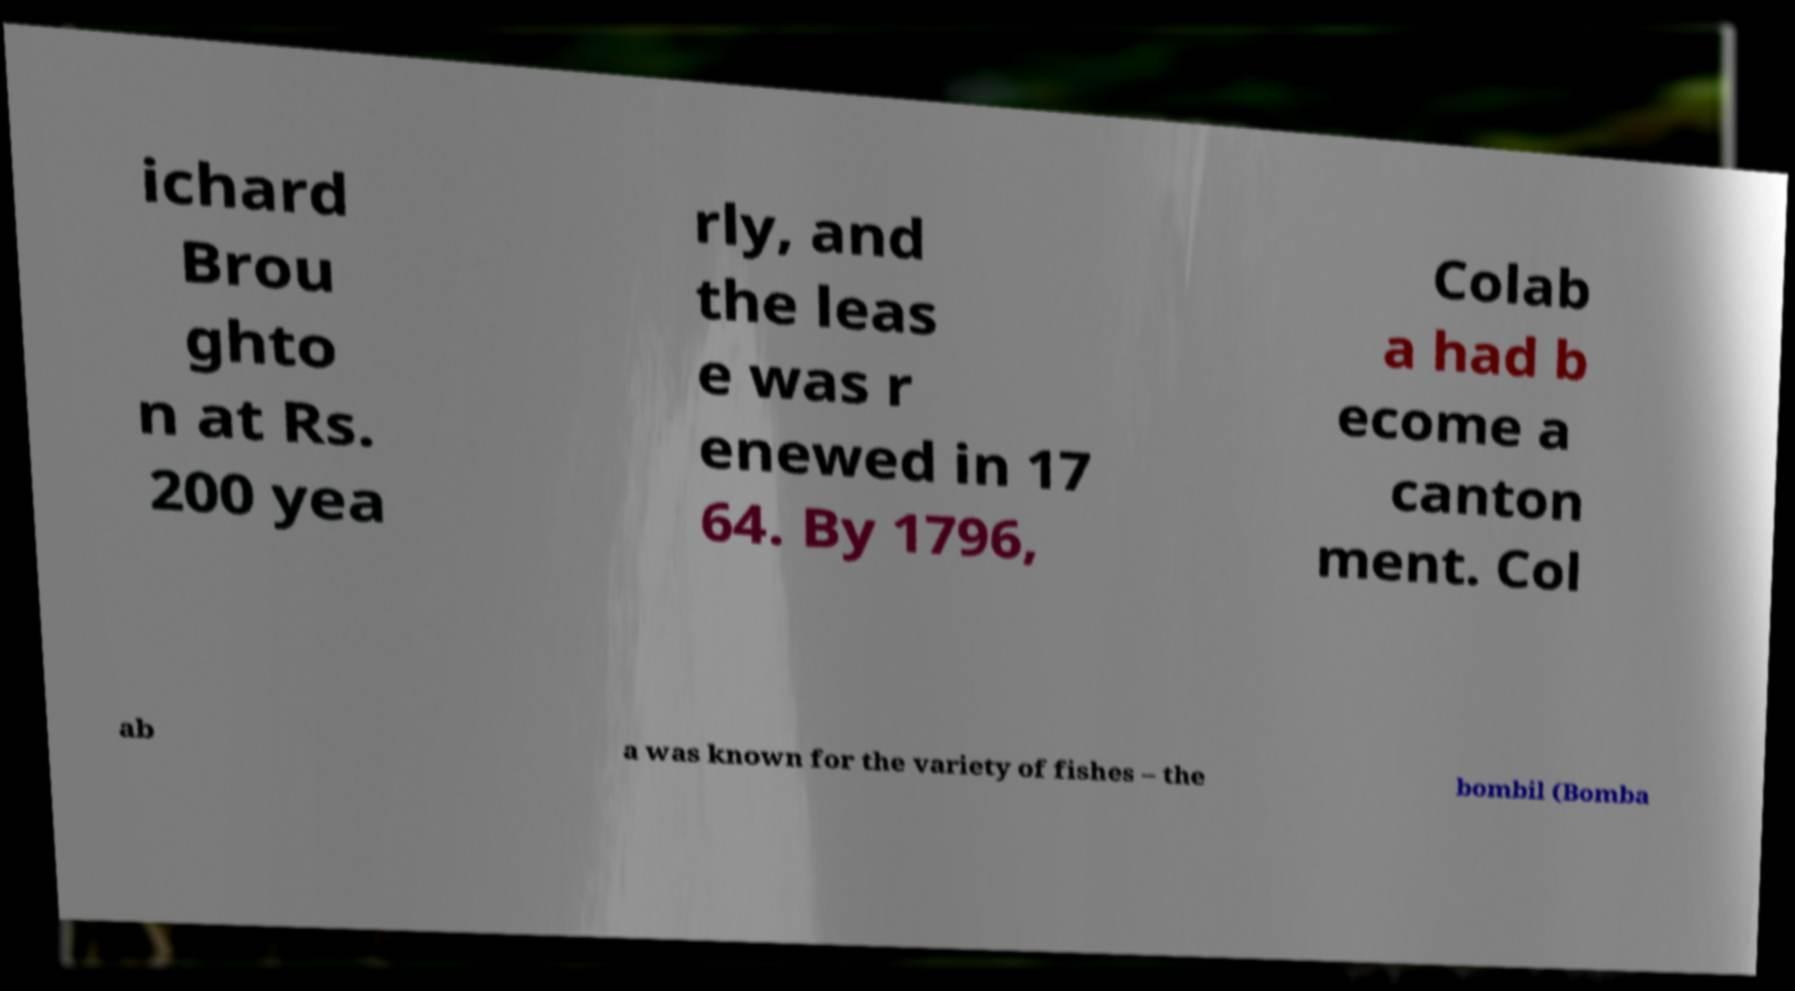What messages or text are displayed in this image? I need them in a readable, typed format. ichard Brou ghto n at Rs. 200 yea rly, and the leas e was r enewed in 17 64. By 1796, Colab a had b ecome a canton ment. Col ab a was known for the variety of fishes – the bombil (Bomba 